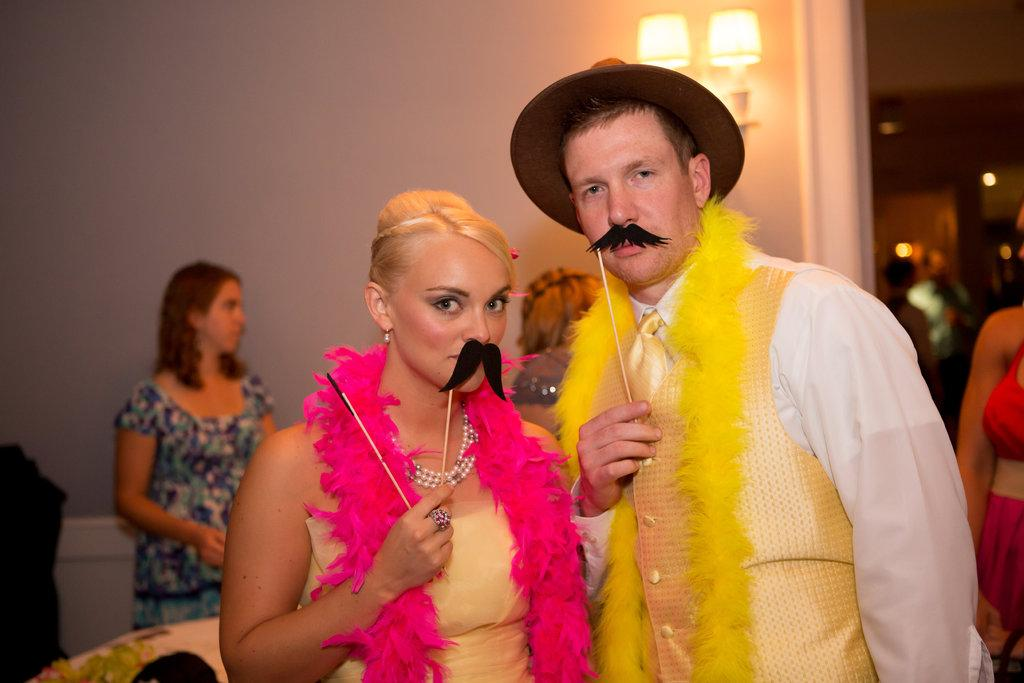How many people are in the image? There are people in the image. What are two of the people holding? Two of the people are holding artificial mustaches. What else are two of the people holding? Two of the people are holding sticks. What can be seen in the background of the image? There are lights and a wall in the background. How is the background of the image depicted? The background is blurred. What type of prose is being recited by the grandfather in the image? There is no grandfather or prose recitation present in the image. What force is being applied by the people holding the sticks in the image? There is no indication of force being applied by the people holding the sticks in the image. 